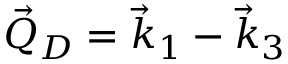Convert formula to latex. <formula><loc_0><loc_0><loc_500><loc_500>\vec { Q } _ { D } = \vec { k } _ { 1 } - \vec { k } _ { 3 }</formula> 